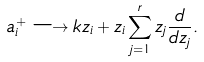<formula> <loc_0><loc_0><loc_500><loc_500>a _ { i } ^ { + } \longrightarrow k z _ { i } + z _ { i } \sum _ { j = 1 } ^ { r } z _ { j } \frac { d } { d z _ { j } } .</formula> 